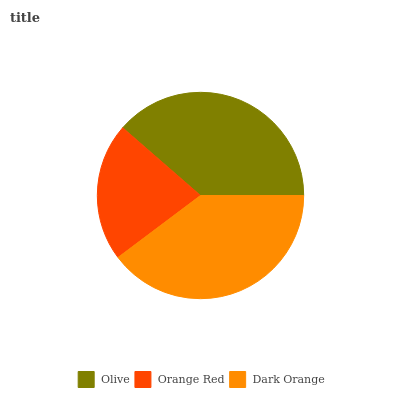Is Orange Red the minimum?
Answer yes or no. Yes. Is Dark Orange the maximum?
Answer yes or no. Yes. Is Dark Orange the minimum?
Answer yes or no. No. Is Orange Red the maximum?
Answer yes or no. No. Is Dark Orange greater than Orange Red?
Answer yes or no. Yes. Is Orange Red less than Dark Orange?
Answer yes or no. Yes. Is Orange Red greater than Dark Orange?
Answer yes or no. No. Is Dark Orange less than Orange Red?
Answer yes or no. No. Is Olive the high median?
Answer yes or no. Yes. Is Olive the low median?
Answer yes or no. Yes. Is Dark Orange the high median?
Answer yes or no. No. Is Orange Red the low median?
Answer yes or no. No. 